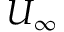Convert formula to latex. <formula><loc_0><loc_0><loc_500><loc_500>U _ { \infty }</formula> 